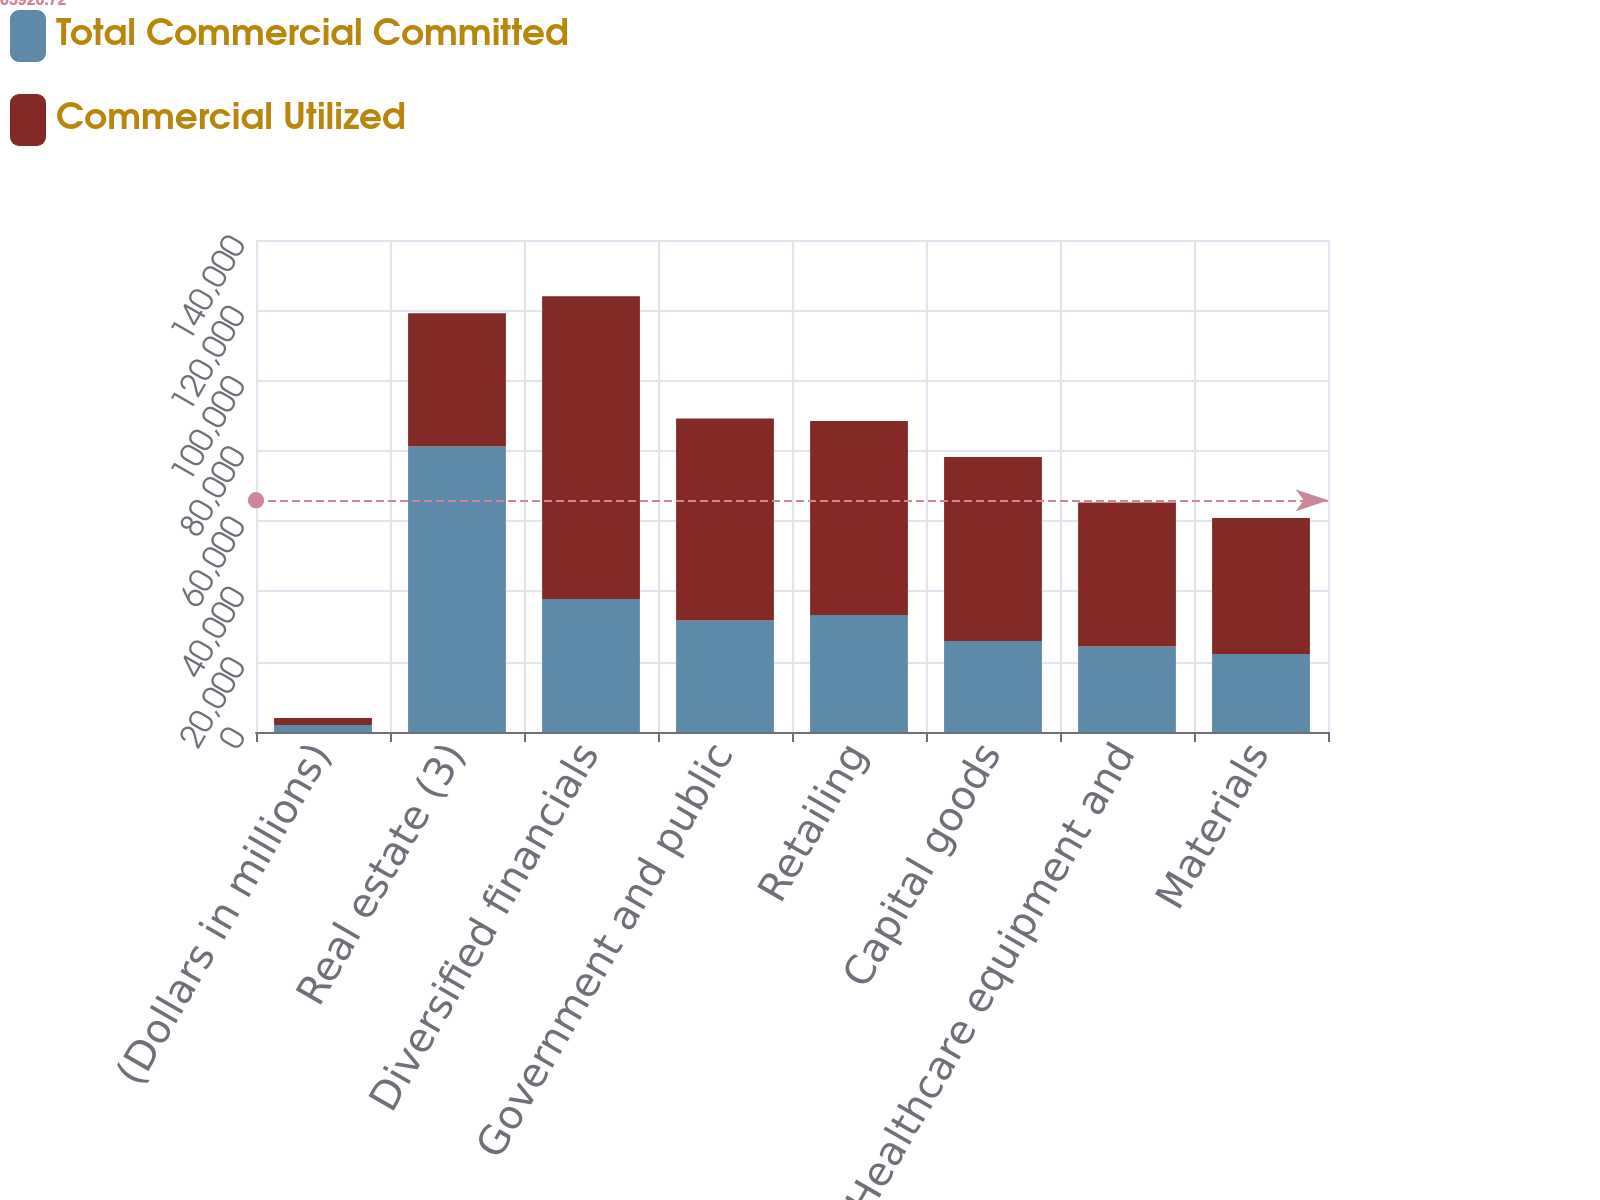<chart> <loc_0><loc_0><loc_500><loc_500><stacked_bar_chart><ecel><fcel>(Dollars in millions)<fcel>Real estate (3)<fcel>Diversified financials<fcel>Government and public<fcel>Retailing<fcel>Capital goods<fcel>Healthcare equipment and<fcel>Materials<nl><fcel>Total Commercial Committed<fcel>2007<fcel>81260<fcel>37872<fcel>31743<fcel>33280<fcel>25908<fcel>24337<fcel>22176<nl><fcel>Commercial Utilized<fcel>2007<fcel>37872<fcel>86118<fcel>57437<fcel>55184<fcel>52356<fcel>40962<fcel>38717<nl></chart> 